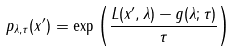<formula> <loc_0><loc_0><loc_500><loc_500>p _ { \lambda , \tau } ( x ^ { \prime } ) = \exp \left ( \frac { L ( x ^ { \prime } , \lambda ) - g ( \lambda ; \tau ) } { \tau } \right )</formula> 